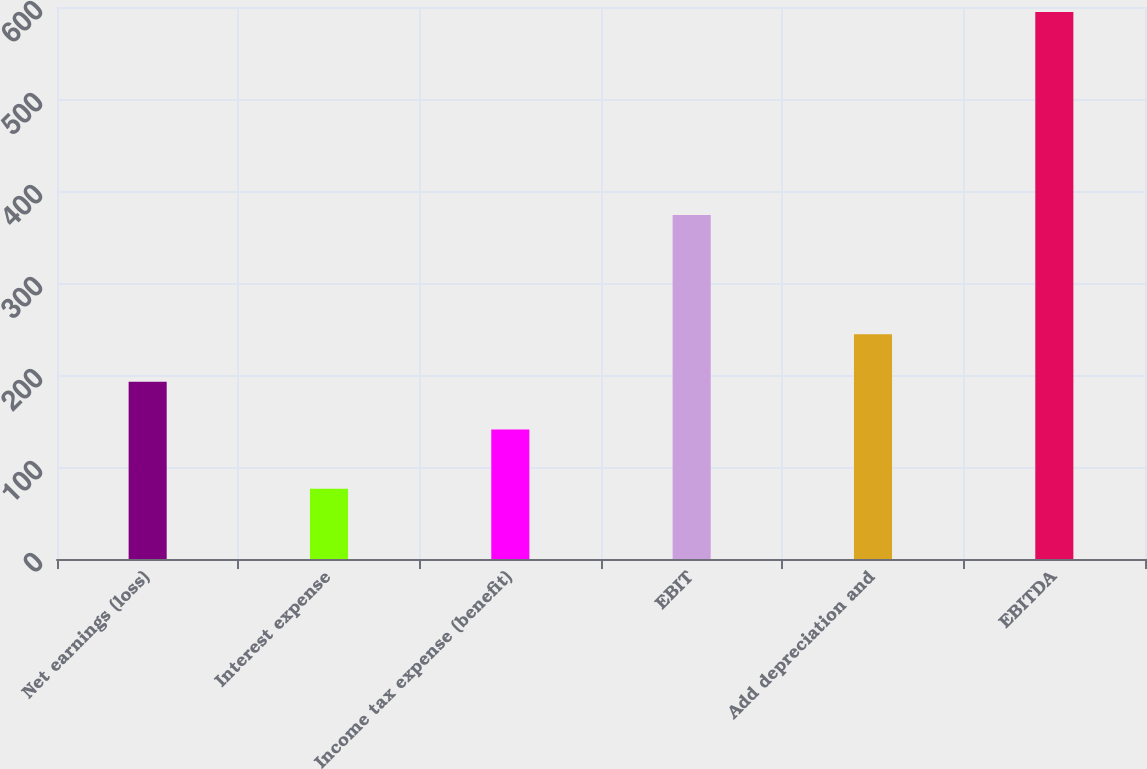<chart> <loc_0><loc_0><loc_500><loc_500><bar_chart><fcel>Net earnings (loss)<fcel>Interest expense<fcel>Income tax expense (benefit)<fcel>EBIT<fcel>Add depreciation and<fcel>EBITDA<nl><fcel>192.61<fcel>76.4<fcel>140.8<fcel>373.9<fcel>244.42<fcel>594.5<nl></chart> 